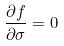Convert formula to latex. <formula><loc_0><loc_0><loc_500><loc_500>\frac { \partial f } { \partial \sigma } = 0</formula> 